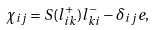<formula> <loc_0><loc_0><loc_500><loc_500>\chi _ { i j } = S ( l ^ { + } _ { i k } ) l ^ { - } _ { k i } - \delta _ { i j } e ,</formula> 